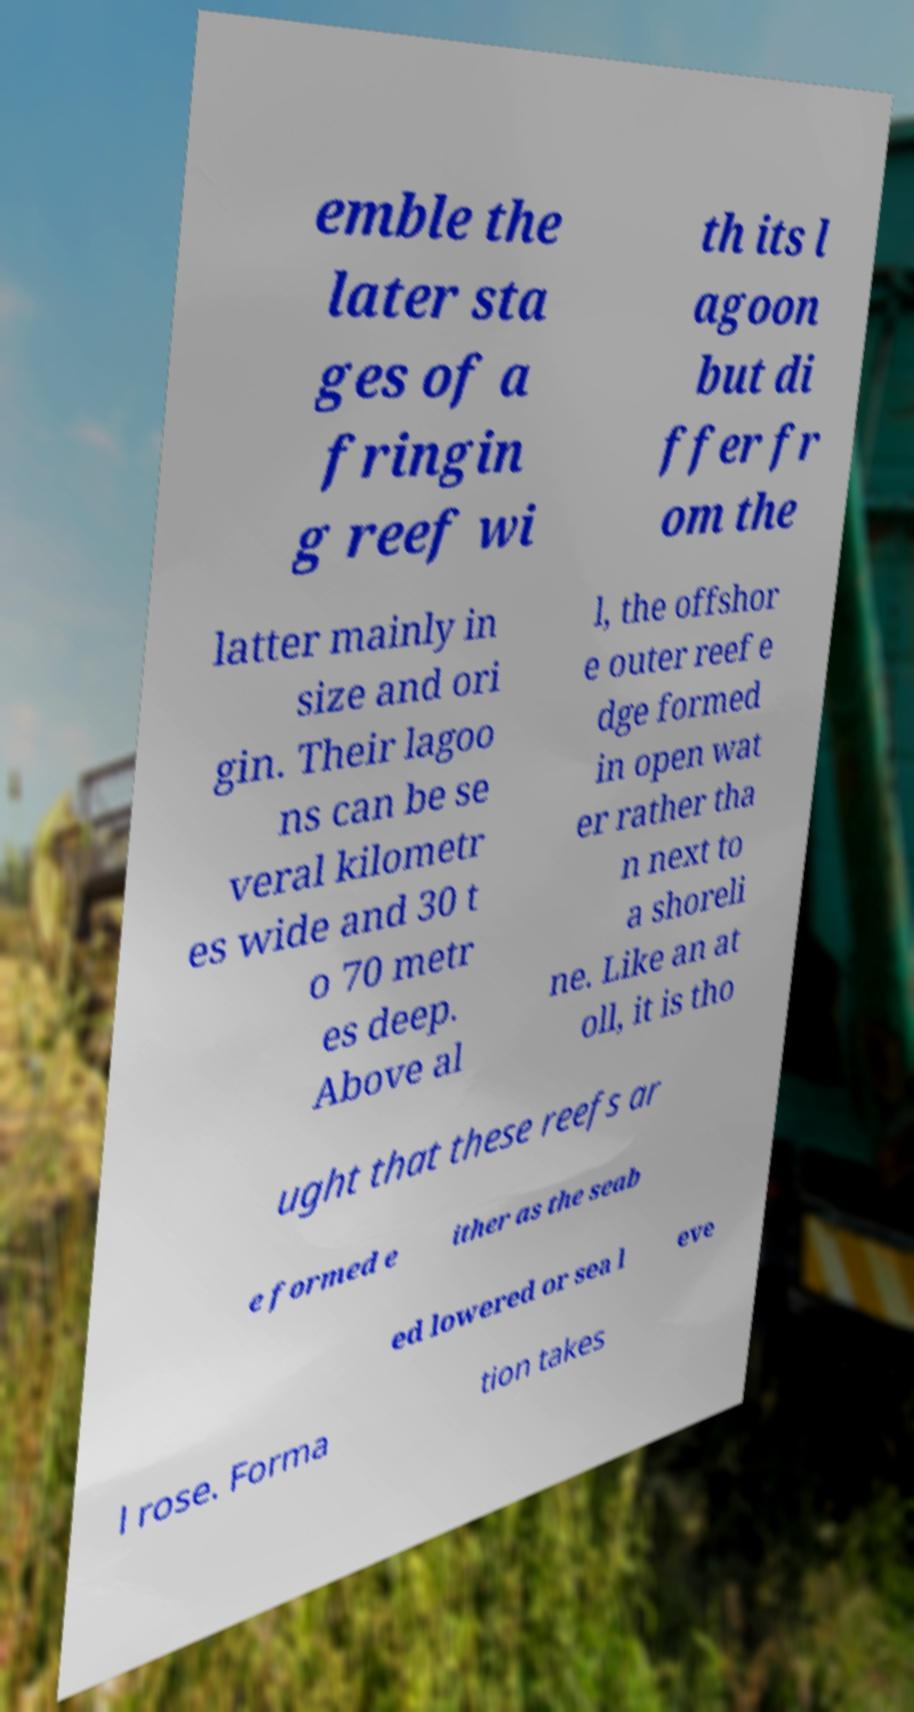Please identify and transcribe the text found in this image. emble the later sta ges of a fringin g reef wi th its l agoon but di ffer fr om the latter mainly in size and ori gin. Their lagoo ns can be se veral kilometr es wide and 30 t o 70 metr es deep. Above al l, the offshor e outer reef e dge formed in open wat er rather tha n next to a shoreli ne. Like an at oll, it is tho ught that these reefs ar e formed e ither as the seab ed lowered or sea l eve l rose. Forma tion takes 